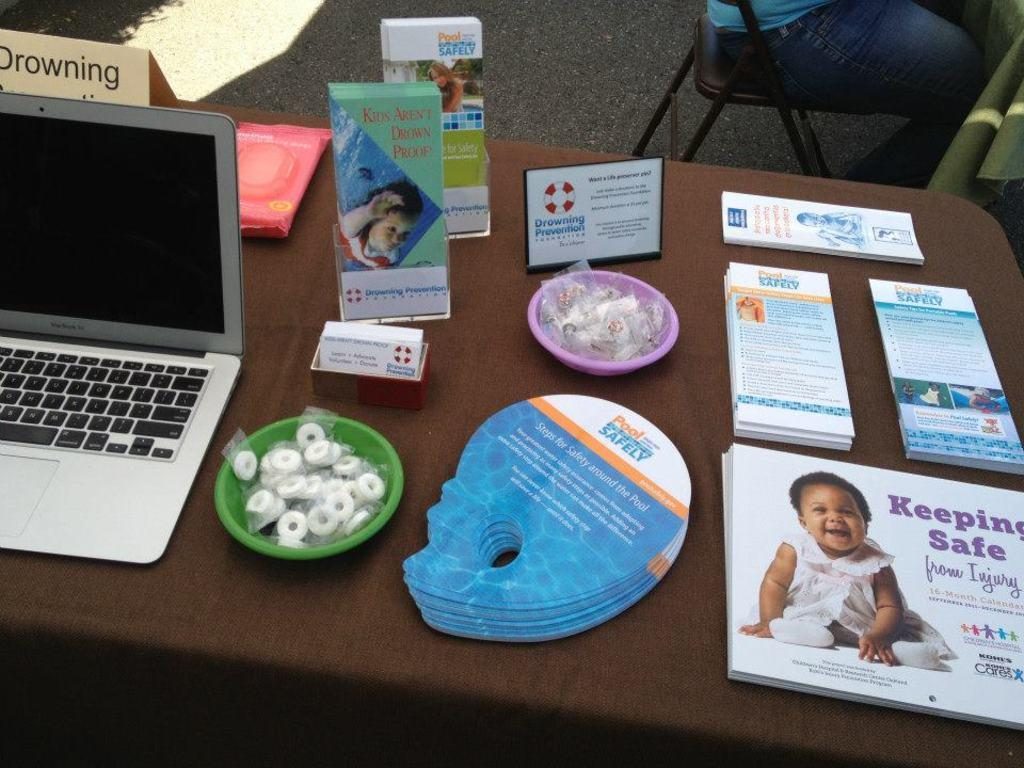<image>
Render a clear and concise summary of the photo. The table has a laptop on it next to brochures for keeping safe and pool safety. 